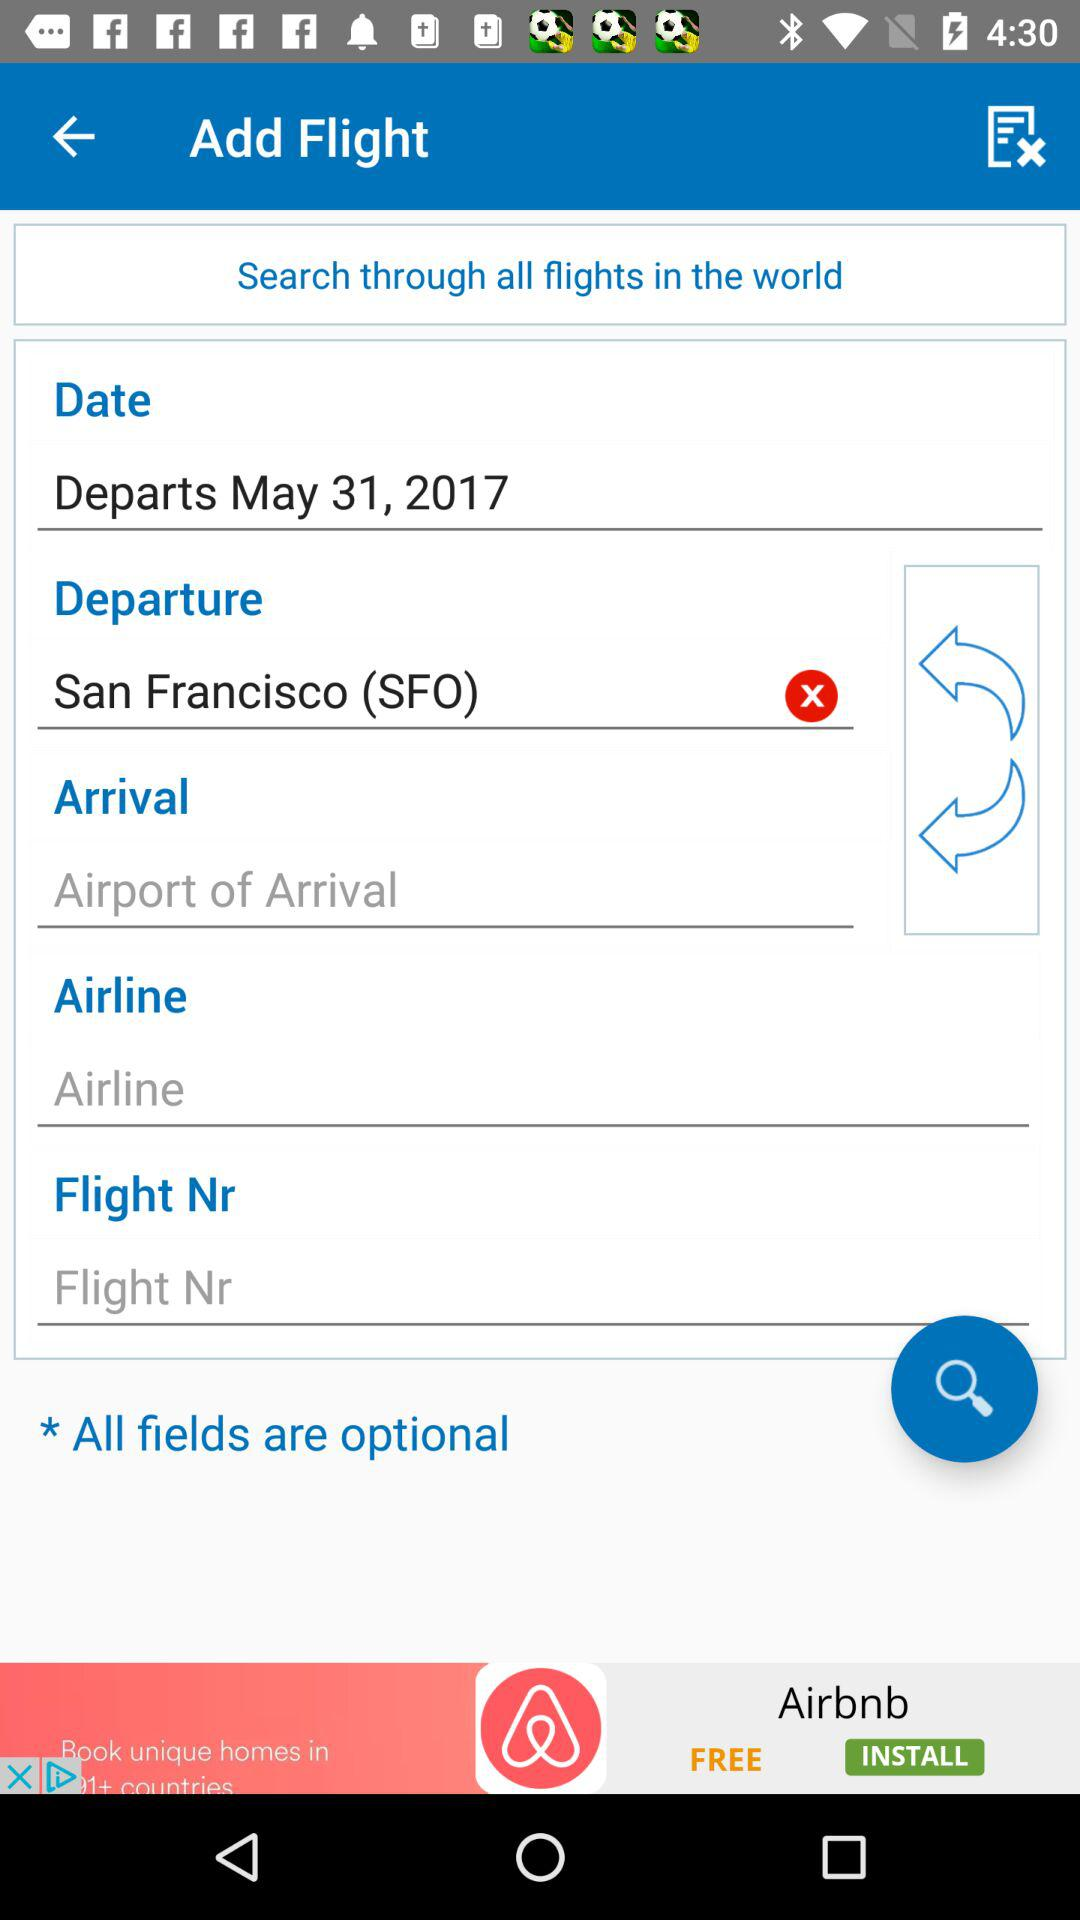What is the departure location? The departure location is San Francisco (SFO). 